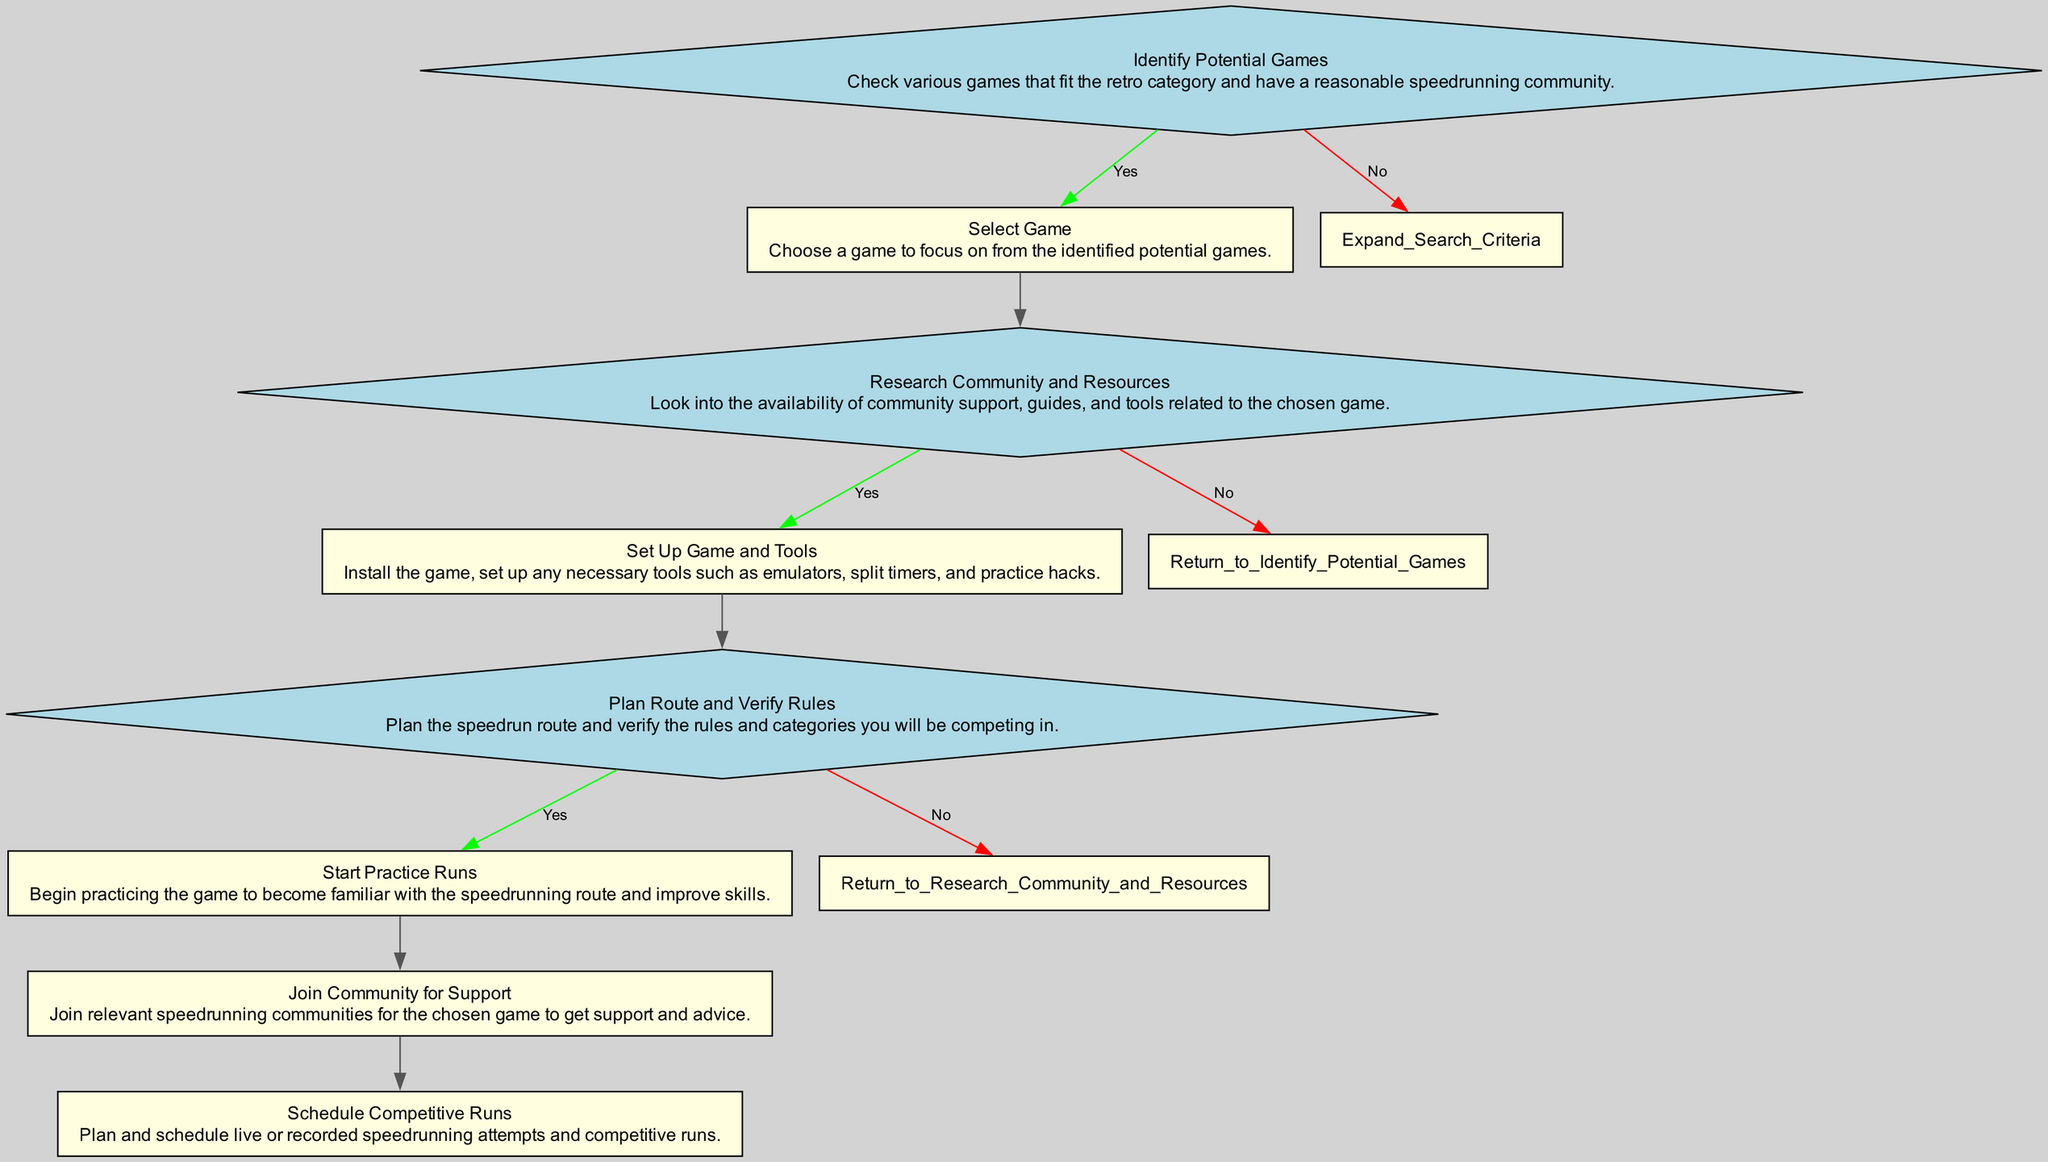What is the first step in the process? The diagram indicates that the first step is "Identify Potential Games." This is the top node in the flow chart and it starts the process for selecting a speedrunning game.
Answer: Identify Potential Games How many decision points are in the process? By analyzing the diagram, there are four decision points: "Identify Potential Games," "Research Community and Resources," "Plan Route and Verify Rules." Thus, the total is three.
Answer: Three What is the next step after "Set Up Game and Tools"? The flow chart shows that after "Set Up Game and Tools," the process proceeds to "Plan Route and Verify Rules," which is the following non-decision node connected to it.
Answer: Plan Route and Verify Rules If you select a game but do not find community resources, where do you go next? The flow chart indicates that if community resources are not available after selecting a game, you would "Return to Identify Potential Games," thus looping back to the first decision point to search for another game.
Answer: Return to Identify Potential Games What happens if you do not select a game after identifying potential games? The flow chart states that if a game is not selected, the next step is "Expand Search Criteria," indicating that you explore other options instead of making a selection.
Answer: Expand Search Criteria After planning your route and verifying rules, what is the next action? Looking at the diagram, the subsequent action after planning the route and verifying rules is to "Start Practice Runs," indicating that practical preparation follows this step.
Answer: Start Practice Runs What does "Join Community for Support" relate to? In the process, "Join Community for Support" is a final node indicating a supportive action that occurs after setting up the speedrunning tools and practicing. It focuses on obtaining community assistance.
Answer: Join Community for Support What would you do if you find community resources available for the selected game? The flow chart indicates that if community resources are available, you would proceed to "Set Up Game and Tools," demonstrating the flow from research to action based on availability.
Answer: Set Up Game and Tools 